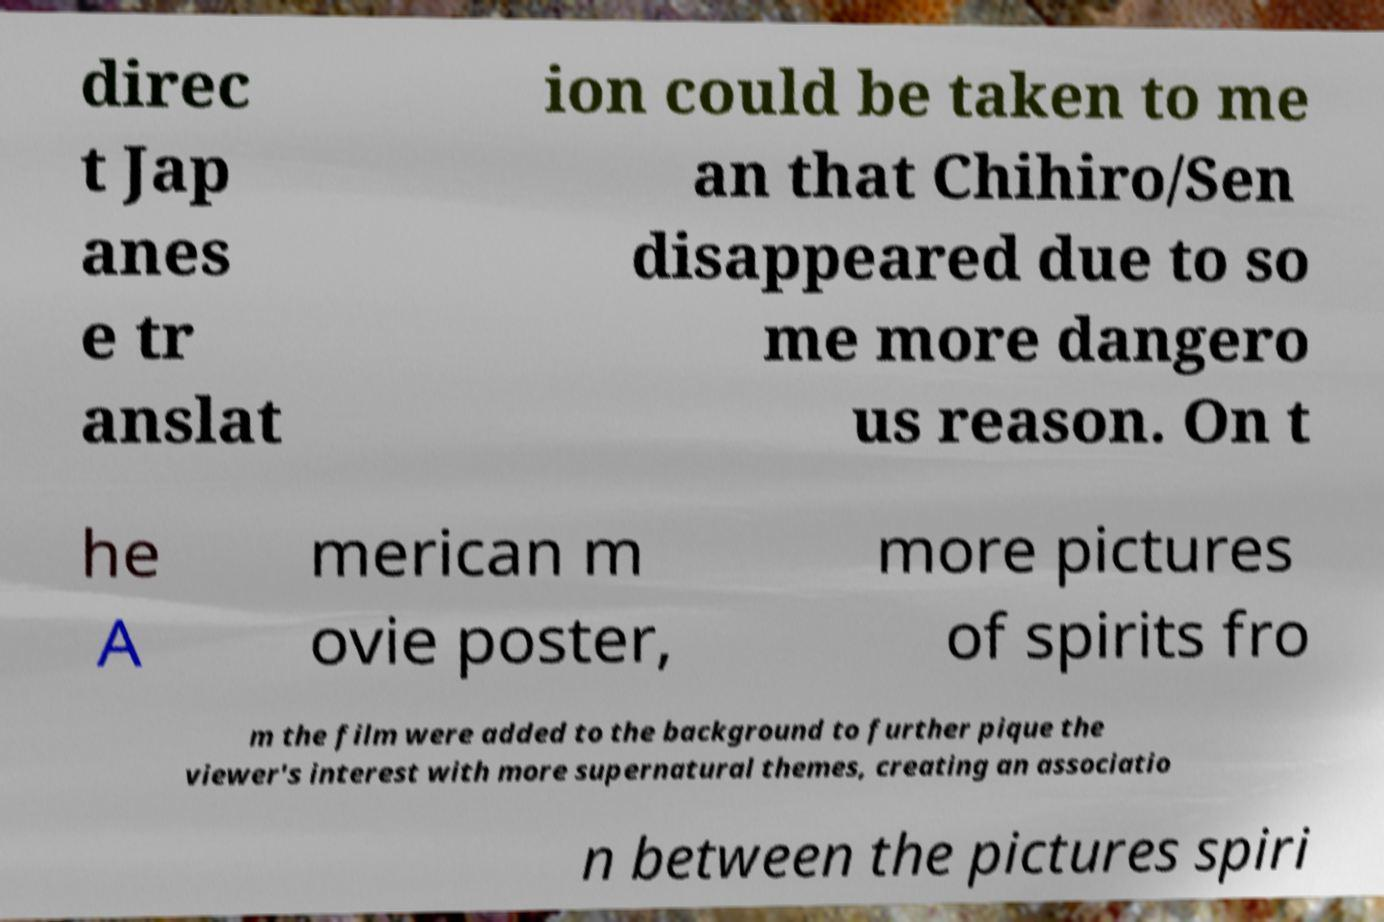Could you assist in decoding the text presented in this image and type it out clearly? direc t Jap anes e tr anslat ion could be taken to me an that Chihiro/Sen disappeared due to so me more dangero us reason. On t he A merican m ovie poster, more pictures of spirits fro m the film were added to the background to further pique the viewer's interest with more supernatural themes, creating an associatio n between the pictures spiri 